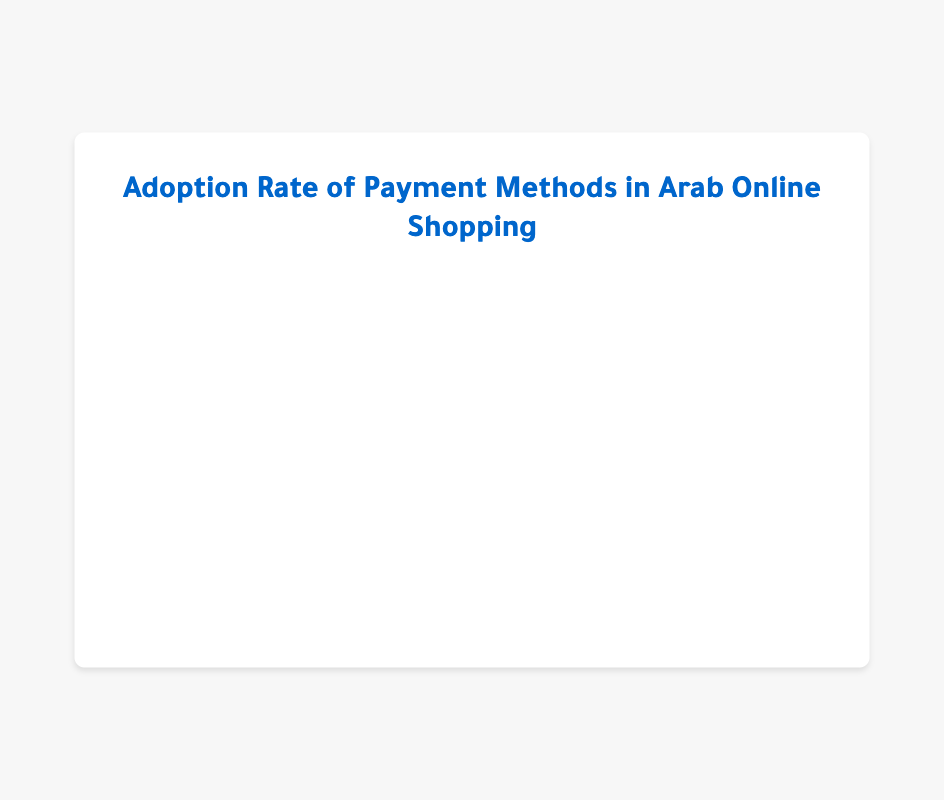Which payment method has the highest adoption rate? The bar representing "Credit/Debit Cards" is the longest and therefore has the highest adoption rate of 45%.
Answer: Credit/Debit Cards Which two payment methods have the same adoption rates? The bars for "Bank Transfers" and "E-Wallets (PayPal, M-Pesa, etc.)" are of equal length, both showing an adoption rate of 5%.
Answer: Bank Transfers and E-Wallets (PayPal, M-Pesa, etc.) What is the difference in adoption rates between the most and least popular payment methods? The most popular method is "Credit/Debit Cards" at 45% and the least popular are "Bank Transfers" and "E-Wallets (PayPal, M-Pesa, etc.)" both at 5%. The difference is 45% - 5% = 40%.
Answer: 40% What are the top two payment methods in terms of adoption rate? The bars for "Credit/Debit Cards" and "Cash on Delivery" are the two longest, representing adoption rates of 45% and 30%, respectively.
Answer: Credit/Debit Cards and Cash on Delivery How much more popular are "Credit/Debit Cards" compared to "Mobile Payments"? "Credit/Debit Cards" have an adoption rate of 45% and "Mobile Payments" have 15%. The difference is 45% - 15% = 30%.
Answer: 30% What proportion of respondents use "Cash on Delivery" compared to "Credit/Debit Cards"? "Cash on Delivery" has an adoption rate of 30%, whereas "Credit/Debit Cards" is at 45%. The proportion is 30/45 = 2/3 or approximately 0.67.
Answer: Approximately 0.67 Which payment method has an adoption rate closer to "Bank Transfers"? Both "Bank Transfers" and "E-Wallets (PayPal, M-Pesa, etc.)" have the same adoption rate of 5%, so they are equally close.
Answer: E-Wallets (PayPal, M-Pesa, etc.) What is the sum of the adoption rates of all payment methods? Summing up all the adoption rates: 45% + 30% + 15% + 5% + 5% = 100%.
Answer: 100% What is the average adoption rate of all payment methods? Sum the adoption rates to get 100%, and divide by the number of methods (5): 100% / 5 = 20%.
Answer: 20% In visual terms, which bar is the shortest? The shortest bars on the chart represent "Bank Transfers" and "E-Wallets (PayPal, M-Pesa, etc.)" both with an adoption rate of 5%.
Answer: Bank Transfers and E-Wallets (PayPal, M-Pesa, etc.) 